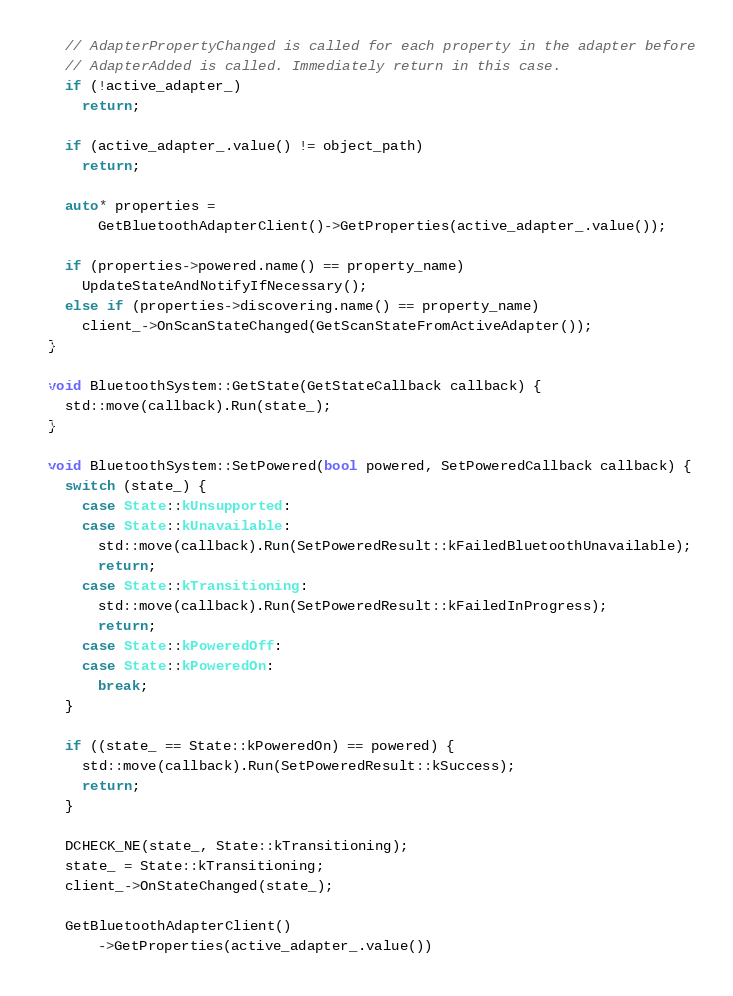<code> <loc_0><loc_0><loc_500><loc_500><_C++_>  // AdapterPropertyChanged is called for each property in the adapter before
  // AdapterAdded is called. Immediately return in this case.
  if (!active_adapter_)
    return;

  if (active_adapter_.value() != object_path)
    return;

  auto* properties =
      GetBluetoothAdapterClient()->GetProperties(active_adapter_.value());

  if (properties->powered.name() == property_name)
    UpdateStateAndNotifyIfNecessary();
  else if (properties->discovering.name() == property_name)
    client_->OnScanStateChanged(GetScanStateFromActiveAdapter());
}

void BluetoothSystem::GetState(GetStateCallback callback) {
  std::move(callback).Run(state_);
}

void BluetoothSystem::SetPowered(bool powered, SetPoweredCallback callback) {
  switch (state_) {
    case State::kUnsupported:
    case State::kUnavailable:
      std::move(callback).Run(SetPoweredResult::kFailedBluetoothUnavailable);
      return;
    case State::kTransitioning:
      std::move(callback).Run(SetPoweredResult::kFailedInProgress);
      return;
    case State::kPoweredOff:
    case State::kPoweredOn:
      break;
  }

  if ((state_ == State::kPoweredOn) == powered) {
    std::move(callback).Run(SetPoweredResult::kSuccess);
    return;
  }

  DCHECK_NE(state_, State::kTransitioning);
  state_ = State::kTransitioning;
  client_->OnStateChanged(state_);

  GetBluetoothAdapterClient()
      ->GetProperties(active_adapter_.value())</code> 